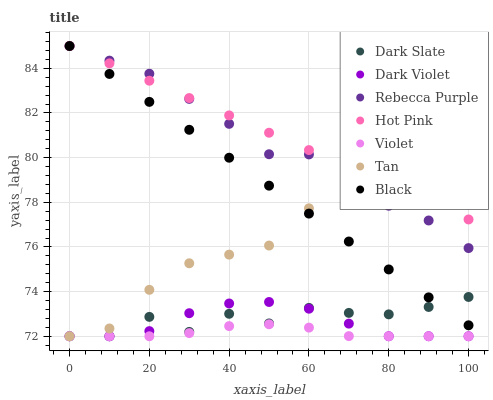Does Violet have the minimum area under the curve?
Answer yes or no. Yes. Does Hot Pink have the maximum area under the curve?
Answer yes or no. Yes. Does Dark Violet have the minimum area under the curve?
Answer yes or no. No. Does Dark Violet have the maximum area under the curve?
Answer yes or no. No. Is Hot Pink the smoothest?
Answer yes or no. Yes. Is Dark Slate the roughest?
Answer yes or no. Yes. Is Dark Violet the smoothest?
Answer yes or no. No. Is Dark Violet the roughest?
Answer yes or no. No. Does Dark Violet have the lowest value?
Answer yes or no. Yes. Does Black have the lowest value?
Answer yes or no. No. Does Rebecca Purple have the highest value?
Answer yes or no. Yes. Does Dark Violet have the highest value?
Answer yes or no. No. Is Dark Slate less than Hot Pink?
Answer yes or no. Yes. Is Black greater than Dark Violet?
Answer yes or no. Yes. Does Violet intersect Tan?
Answer yes or no. Yes. Is Violet less than Tan?
Answer yes or no. No. Is Violet greater than Tan?
Answer yes or no. No. Does Dark Slate intersect Hot Pink?
Answer yes or no. No. 